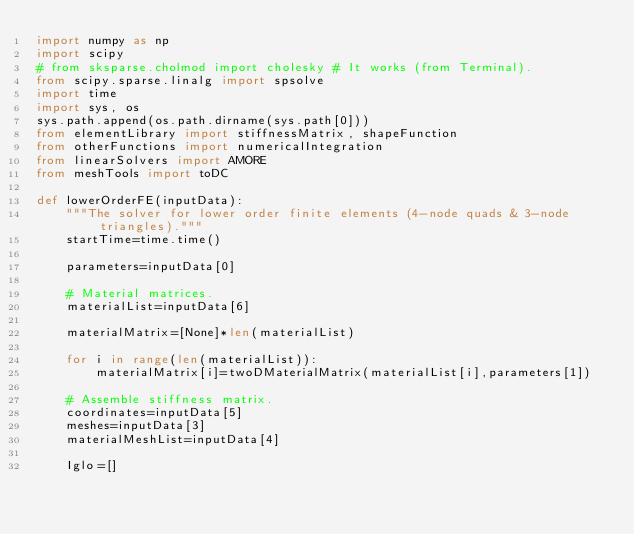Convert code to text. <code><loc_0><loc_0><loc_500><loc_500><_Python_>import numpy as np 
import scipy
# from sksparse.cholmod import cholesky # It works (from Terminal).
from scipy.sparse.linalg import spsolve
import time
import sys, os
sys.path.append(os.path.dirname(sys.path[0]))
from elementLibrary import stiffnessMatrix, shapeFunction
from otherFunctions import numericalIntegration
from linearSolvers import AMORE
from meshTools import toDC

def lowerOrderFE(inputData):
    """The solver for lower order finite elements (4-node quads & 3-node triangles)."""
    startTime=time.time()

    parameters=inputData[0]

    # Material matrices.
    materialList=inputData[6]

    materialMatrix=[None]*len(materialList)

    for i in range(len(materialList)):
        materialMatrix[i]=twoDMaterialMatrix(materialList[i],parameters[1])
    
    # Assemble stiffness matrix.
    coordinates=inputData[5]
    meshes=inputData[3]
    materialMeshList=inputData[4]

    Iglo=[]</code> 